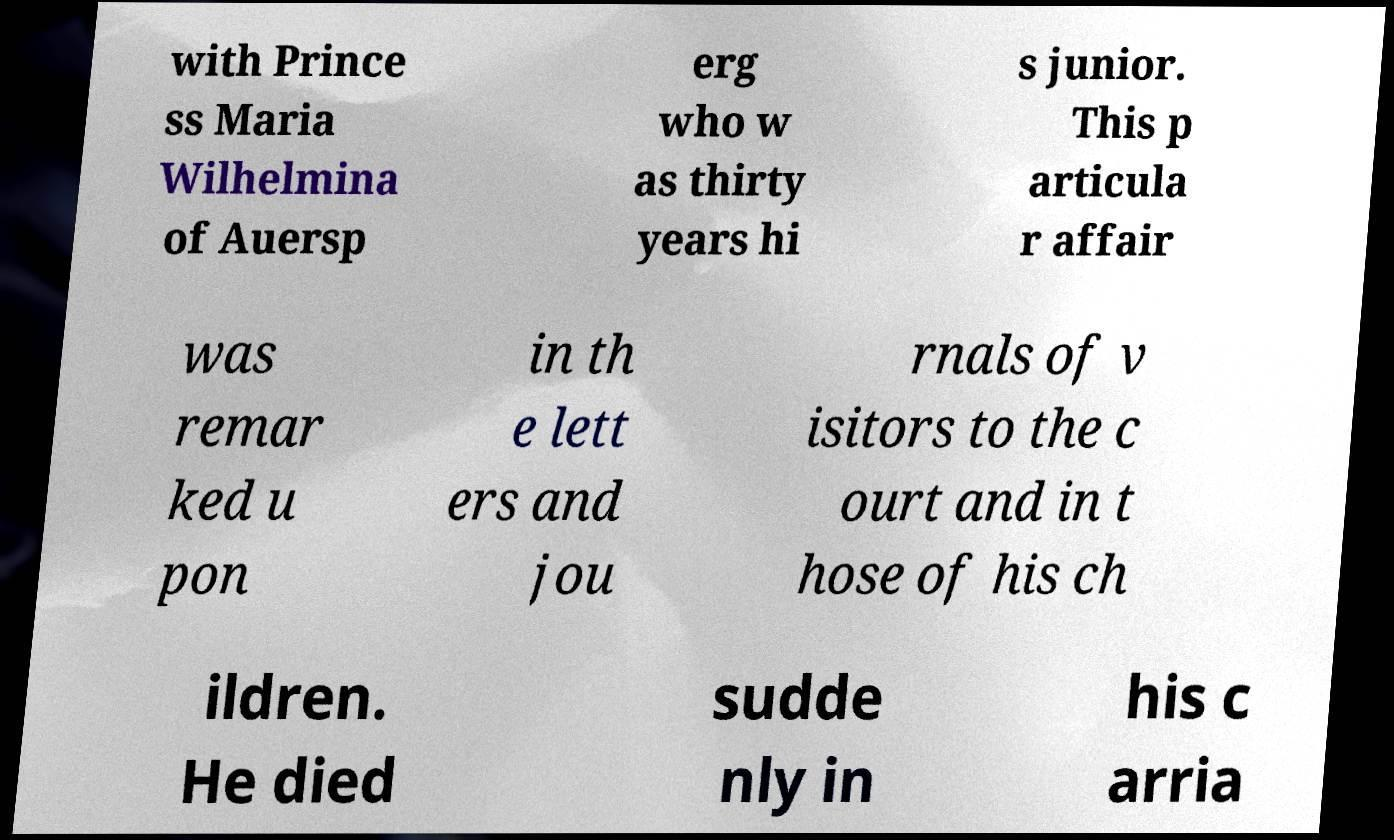There's text embedded in this image that I need extracted. Can you transcribe it verbatim? with Prince ss Maria Wilhelmina of Auersp erg who w as thirty years hi s junior. This p articula r affair was remar ked u pon in th e lett ers and jou rnals of v isitors to the c ourt and in t hose of his ch ildren. He died sudde nly in his c arria 